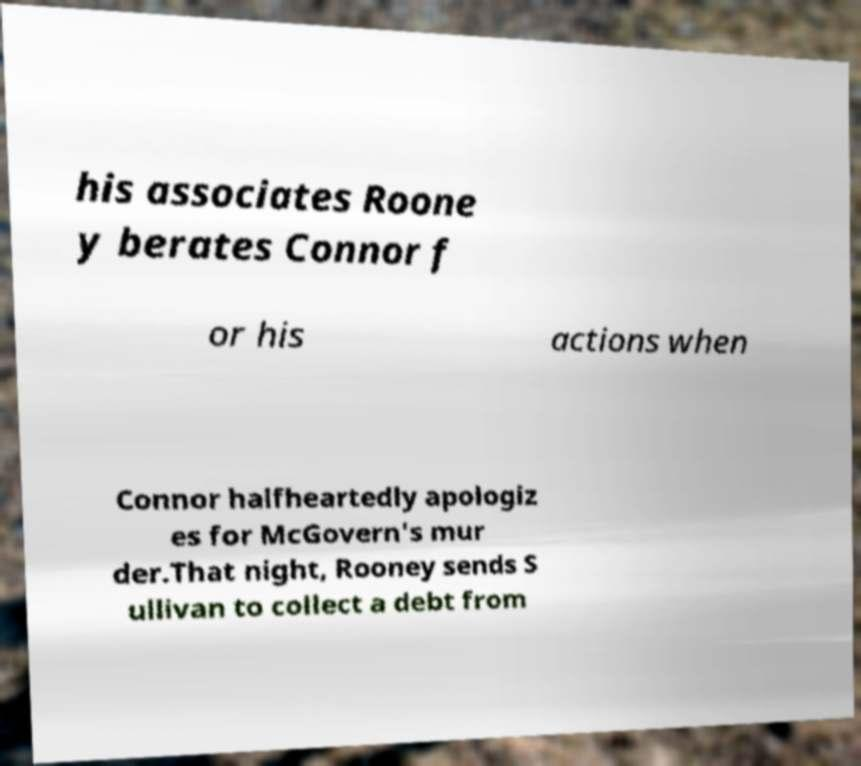There's text embedded in this image that I need extracted. Can you transcribe it verbatim? his associates Roone y berates Connor f or his actions when Connor halfheartedly apologiz es for McGovern's mur der.That night, Rooney sends S ullivan to collect a debt from 